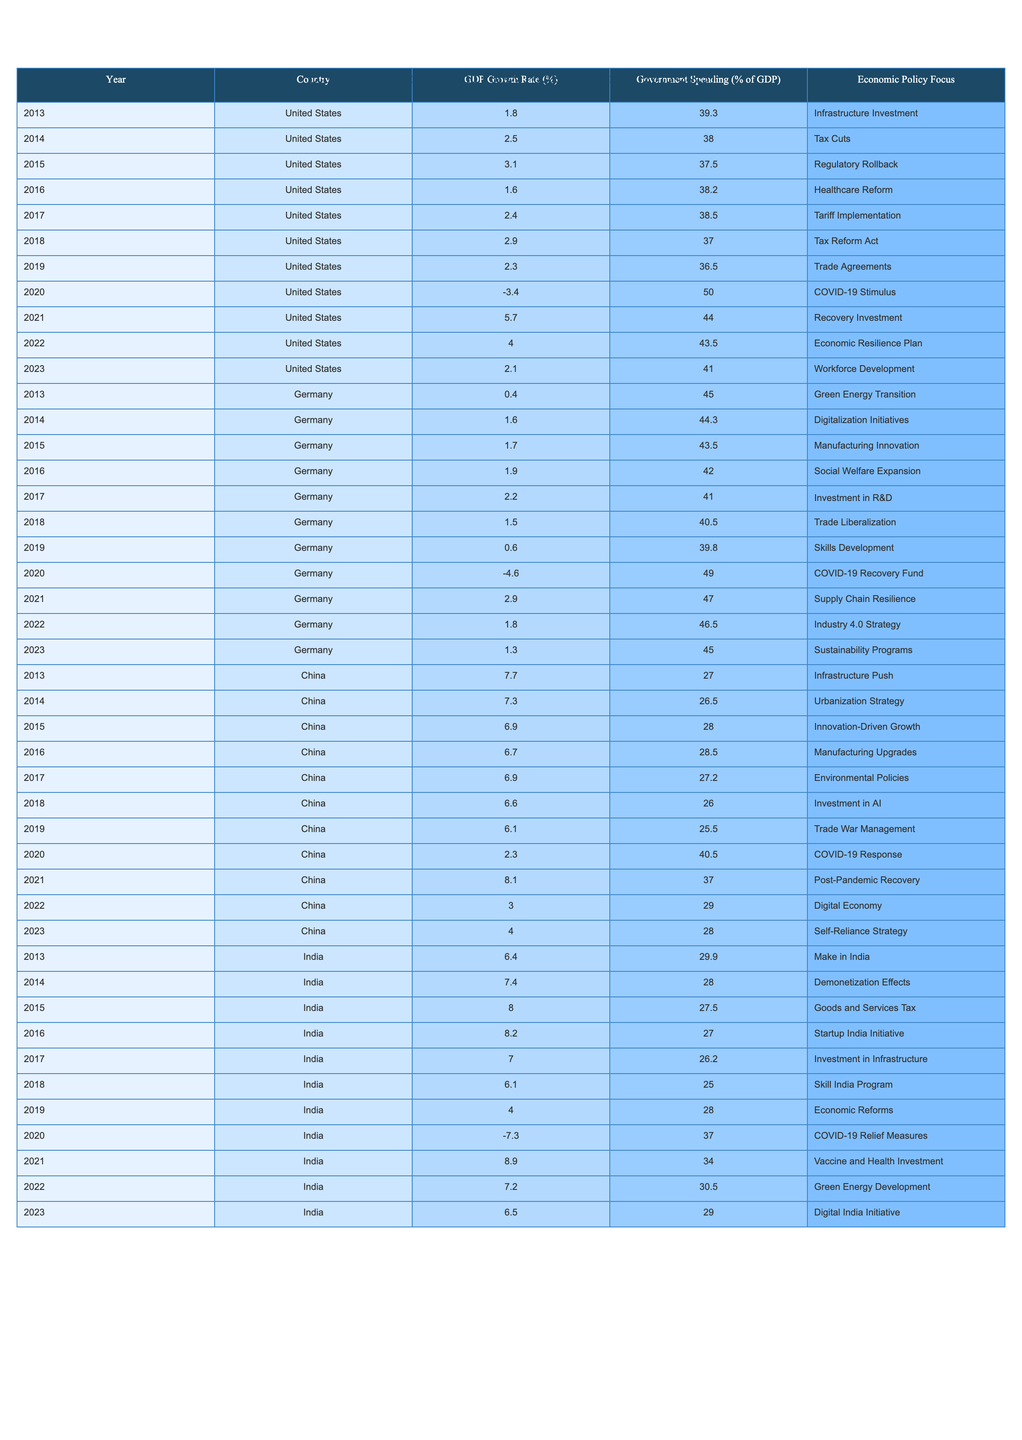What was the GDP Growth Rate of the United States in 2021? In the table, for the year 2021 under the United States, the GDP Growth Rate is listed as 5.7%.
Answer: 5.7% Which country had the highest GDP Growth Rate in 2015? In the table, we can see that India had the highest GDP Growth Rate at 8.0% in 2015.
Answer: India What is the average Government Spending as a percentage of GDP for Germany over the past decade? Adding Germany's government spending percentages (45.0 + 44.3 + 43.5 + 42.0 + 41.0 + 40.5 + 39.8 + 49.0 + 47.0 + 46.5 + 45.0) gives us a total of 459.6%. Dividing by the 11 years results in an average of 41.8%.
Answer: 41.8% Did the GDP Growth Rate for China ever drop below 3% in the provided years? In the table, the lowest GDP Growth Rate for China is 2.3% in 2020, which is below 3%.
Answer: Yes What was the trend in GDP Growth Rates for India from 2013 to 2023? Looking at the data points from 2013 to 2023, we observe an increase until 2016, then it fluctuates, with the lowest point in 2020 and an overall upward trend from 2021 to 2023, ending at 6.5%.
Answer: Fluctuating upward trend Which country had the lowest average GDP Growth Rate for the decade? By calculating the average for each country, we find that Germany's average is the lowest at about 1.3% across the years listed, compared to the others.
Answer: Germany How much did the Government Spending as a percentage of GDP in the United States change from 2013 to 2023? The Government Spending percentage in the United States was 39.3% in 2013 and 41.0% in 2023, showing an increase of 1.7%.
Answer: Increased by 1.7% What was the maximum GDP Growth Rate recorded for China within the decade? The highest GDP Growth Rate recorded for China was 8.1% in 2021, which is the maximum in the table.
Answer: 8.1% In which year did India experience a negative GDP Growth Rate, and what was it? India experienced a negative GDP Growth Rate in 2020, where it was -7.3%.
Answer: 2020, -7.3% How does the average Government Spending percentage in 2020 compare among the listed countries? Calculating the averages for 2020: United States (50.0%), Germany (49.0%), China (40.5%), and India (37.0%), shows that the United States had the highest spending at 50.0%.
Answer: United States had the highest Which country's GDP Growth Rate showed a recovery in 2021 after a significant drop? In 2021, China had a GDP Growth Rate of 8.1% compared to 2.3% in 2020, indicating a recovery.
Answer: China 